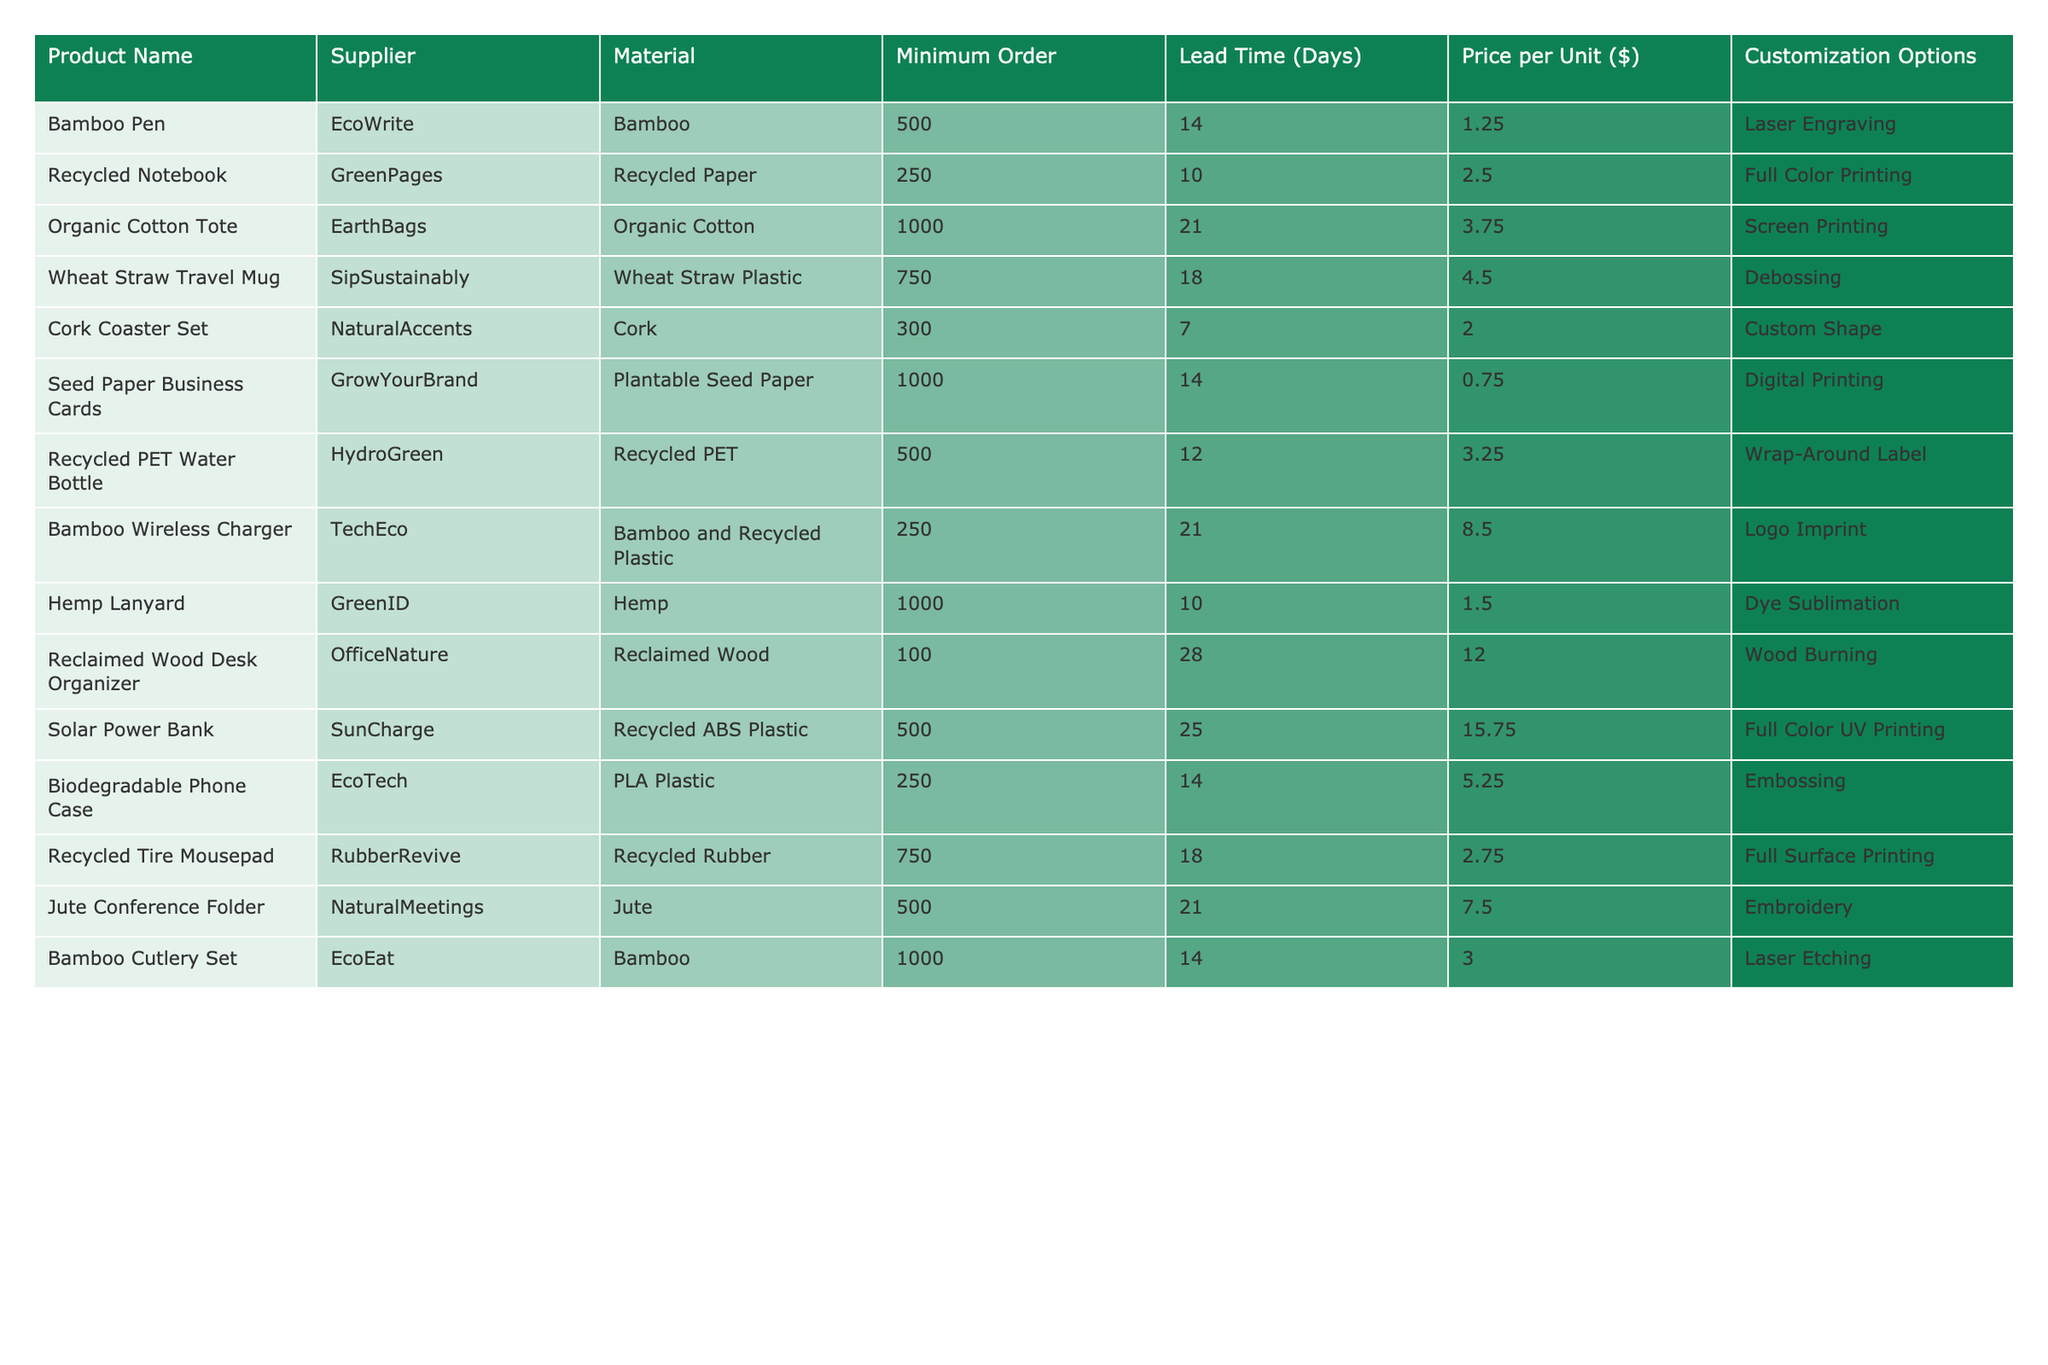What is the minimum order quantity for the Organic Cotton Tote? The Organic Cotton Tote's minimum order is explicitly listed in the table. By scanning through the "Minimum Order" column, we see that it is 1000.
Answer: 1000 Which product has the lowest price per unit? To find the lowest price, we will compare all prices in the "Price per Unit ($)" column. The Seed Paper Business Cards are priced at $0.75, which is the least among the listed products.
Answer: $0.75 How many products have a lead time of 14 days? By checking the "Lead Time (Days)" column, we note that there are two products—Seed Paper Business Cards and Bamboo Pen—that both list a lead time of 14 days.
Answer: 2 What is the total cost for ordering 500 units of the Solar Power Bank? First, we identify the price per unit for the Solar Power Bank from the table, which is $15.75. We then multiply this by the order quantity of 500. So, the total cost is 500 * 15.75 = $7875.
Answer: $7875 Are there any products that can be customized through embroidery? Looking in the "Customization Options" column, we find that the Jute Conference Folder is the only product listed that specifically mentions embroidery as a customization option.
Answer: Yes What is the average price per unit of all products listed? First, we note the prices: $1.25, $2.50, $3.75, $4.50, $2.00, $0.75, $3.25, $8.50, $1.50, $12.00, $15.75, $5.25, $2.75, and $7.50. Adding these together gives 68.75, and since there are 14 products, we then calculate the average as 68.75 / 14, which equals approximately $4.91.
Answer: $4.91 Which product has the longest lead time, and how many days is it? By scanning through the "Lead Time (Days)" column, we can identify that the Solar Power Bank has the maximum lead time of 25 days.
Answer: Solar Power Bank, 25 days What percentage of the products can be customized with laser engraving? There are 14 products in the table, and those that offer customization options of laser engraving are the Bamboo Pen and Bamboo Cutlery Set, totaling 2 products. To find the percentage, we calculate (2 / 14) * 100 = approximately 14.29%.
Answer: 14.29% 